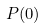<formula> <loc_0><loc_0><loc_500><loc_500>P ( 0 )</formula> 